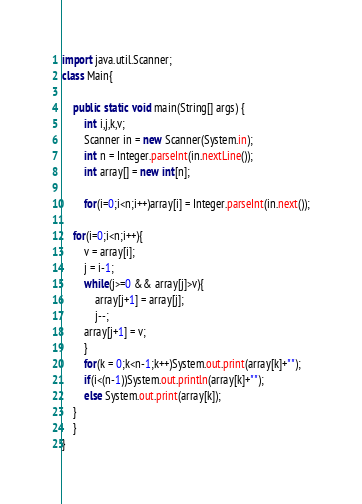<code> <loc_0><loc_0><loc_500><loc_500><_Java_>import java.util.Scanner;
class Main{

	public static void main(String[] args) {
		int i,j,k,v;
		Scanner in = new Scanner(System.in);
		int n = Integer.parseInt(in.nextLine());
		int array[] = new int[n];

		for(i=0;i<n;i++)array[i] = Integer.parseInt(in.next());

	for(i=0;i<n;i++){
		v = array[i];
		j = i-1;
		while(j>=0 && array[j]>v){
			array[j+1] = array[j];
			j--;
		array[j+1] = v;
		}
	    for(k = 0;k<n-1;k++)System.out.print(array[k]+"");
	    if(i<(n-1))System.out.println(array[k]+"");
	    else System.out.print(array[k]);
	}
	}
}</code> 